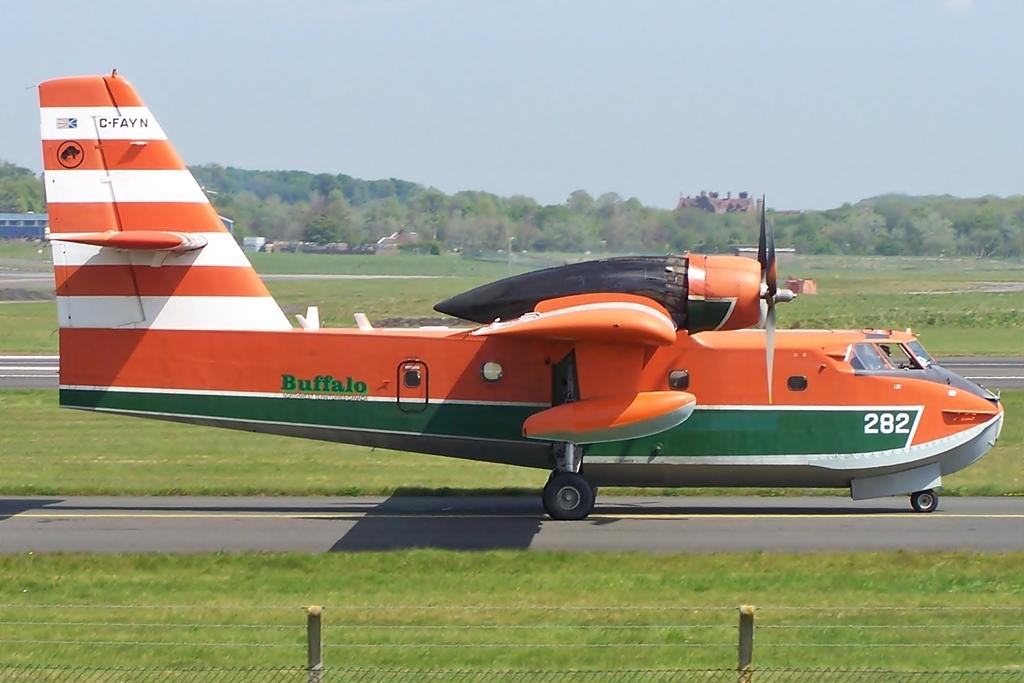What is the unusual object on the road in the image? There is an airplane on the road in the image. What can be seen inside the airplane? People are inside the airplane. What structures are located on the left side of the image? There are buildings on the left side of the image. What type of vegetation is visible in the background of the image? There are trees in the background of the image. What is visible at the top of the image? The sky is visible at the top of the image. What type of reward is being given to the pickle in the image? There is no pickle present in the image, and therefore no reward can be given to it. 